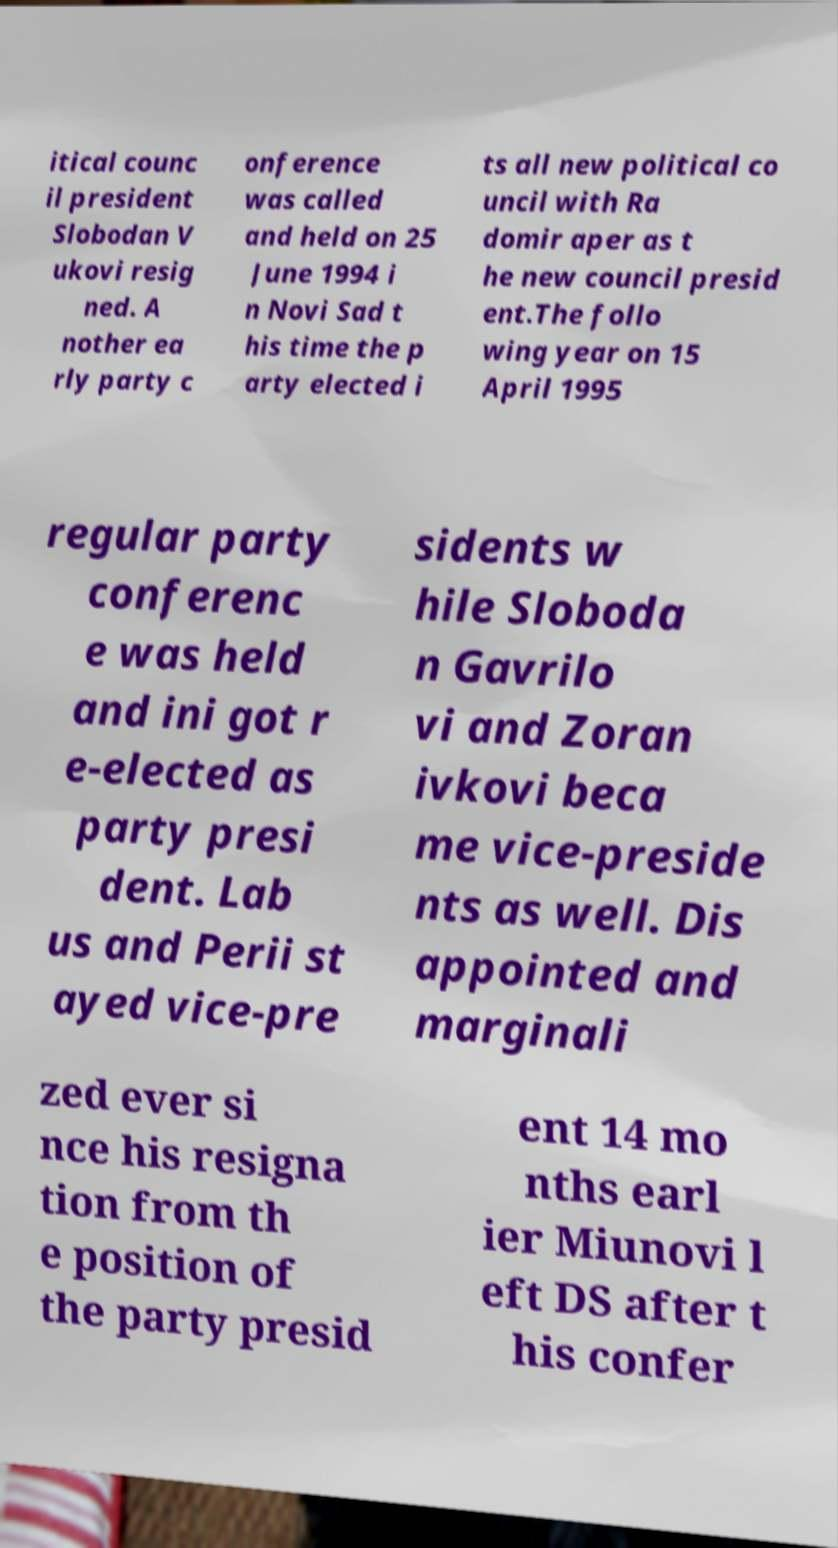Can you accurately transcribe the text from the provided image for me? itical counc il president Slobodan V ukovi resig ned. A nother ea rly party c onference was called and held on 25 June 1994 i n Novi Sad t his time the p arty elected i ts all new political co uncil with Ra domir aper as t he new council presid ent.The follo wing year on 15 April 1995 regular party conferenc e was held and ini got r e-elected as party presi dent. Lab us and Perii st ayed vice-pre sidents w hile Sloboda n Gavrilo vi and Zoran ivkovi beca me vice-preside nts as well. Dis appointed and marginali zed ever si nce his resigna tion from th e position of the party presid ent 14 mo nths earl ier Miunovi l eft DS after t his confer 